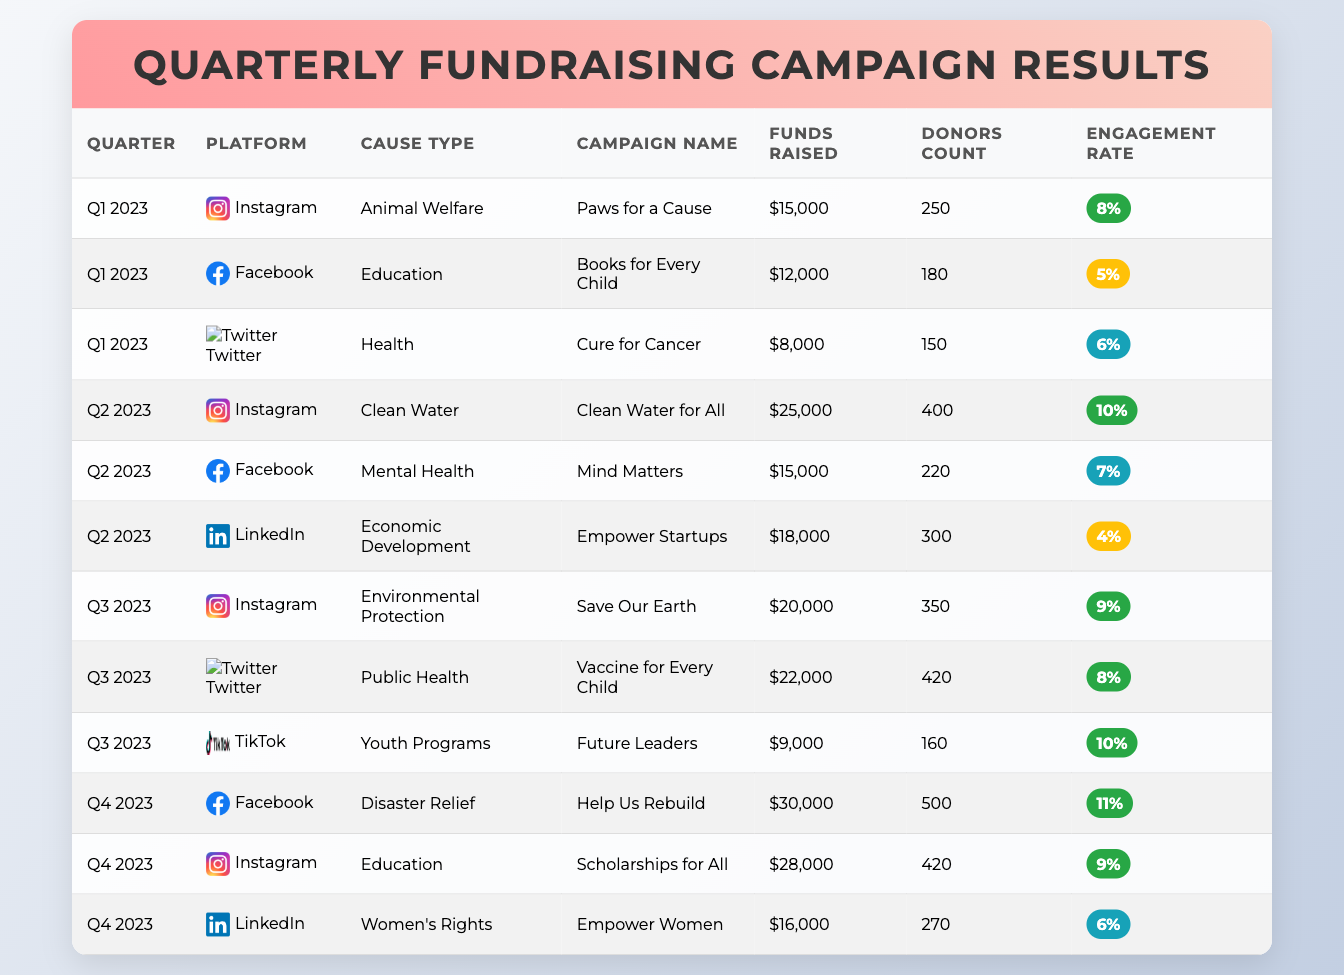What was the total amount raised for the campaign "Help Us Rebuild"? The campaign "Help Us Rebuild" is listed under Q4 2023 in the table, with a funds raised amount of $30,000. Thus, the answer is directly retrieved from the corresponding row.
Answer: $30,000 Which platform had the highest engagement rate in Q2 2023? In Q2 2023, the engagement rates listed are as follows: Instagram (10%), Facebook (7%), and LinkedIn (4%). The highest engagement rate is 10% from Instagram. This involves a simple comparison of the engagement rates across platforms in that quarter.
Answer: Instagram with 10% How much more money was raised in Q4 2023 compared to Q1 2023? In Q4 2023, the total fundraising amounts are: Facebook ($30,000) + Instagram ($28,000) + LinkedIn ($16,000) = $74,000. In Q1 2023, the sums are: Instagram ($15,000) + Facebook ($12,000) + Twitter ($8,000) = $35,000. The difference is $74,000 - $35,000 = $39,000. This requires summing the amounts raised in each quarter and then finding the difference.
Answer: $39,000 Did more donors participate in the "Cure for Cancer" or "Mind Matters" campaign? "Cure for Cancer" had 150 donors in Q1 2023, while "Mind Matters" had 220 donors in Q2 2023. Comparatively, 220 is greater than 150, making the fact-based question a simple comparison.
Answer: "Mind Matters" had more donors What was the average funds raised per campaign on Instagram for 2023? The funds raised from Instagram campaigns for 2023 are as follows: Q1: $15,000; Q2: $25,000; Q3: $20,000; Q4: $28,000. Summing these gives $15,000 + $25,000 + $20,000 + $28,000 = $88,000. There are 4 campaigns, so the average is $88,000 / 4 = $22,000. This involves calculating the total amount raised and dividing it by the number of campaigns.
Answer: $22,000 